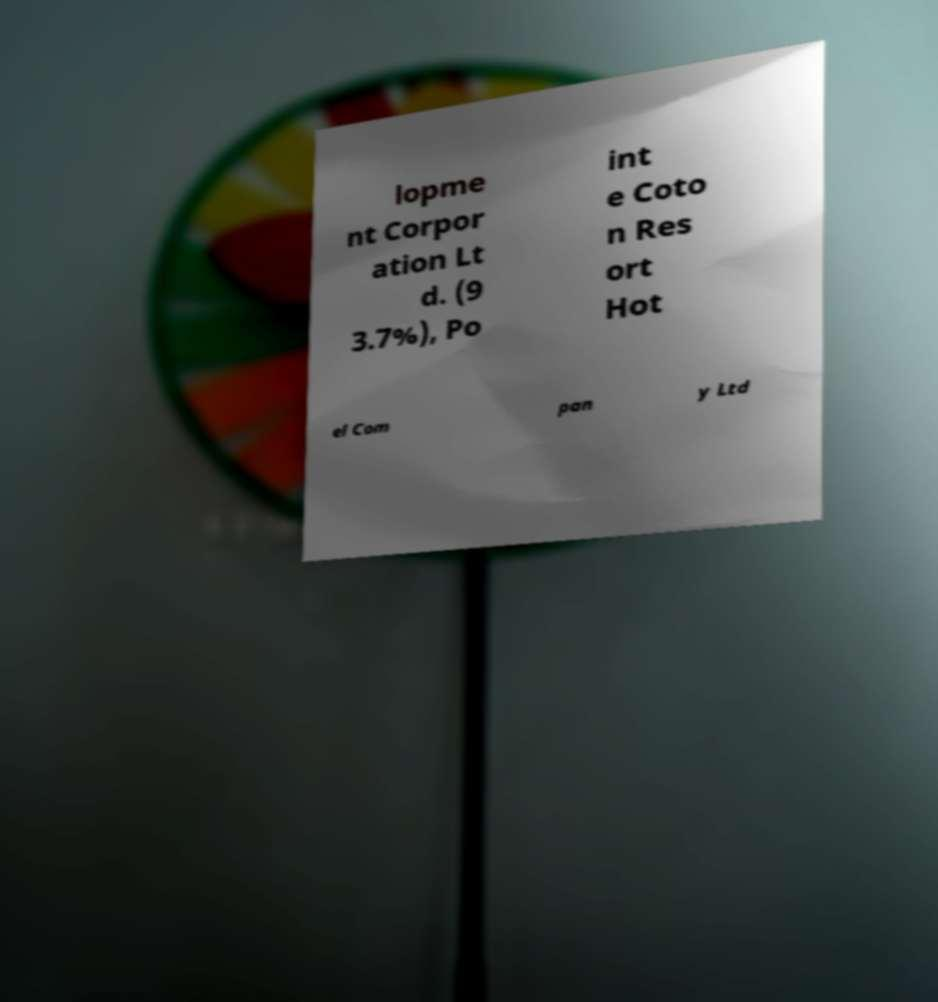Could you extract and type out the text from this image? lopme nt Corpor ation Lt d. (9 3.7%), Po int e Coto n Res ort Hot el Com pan y Ltd 